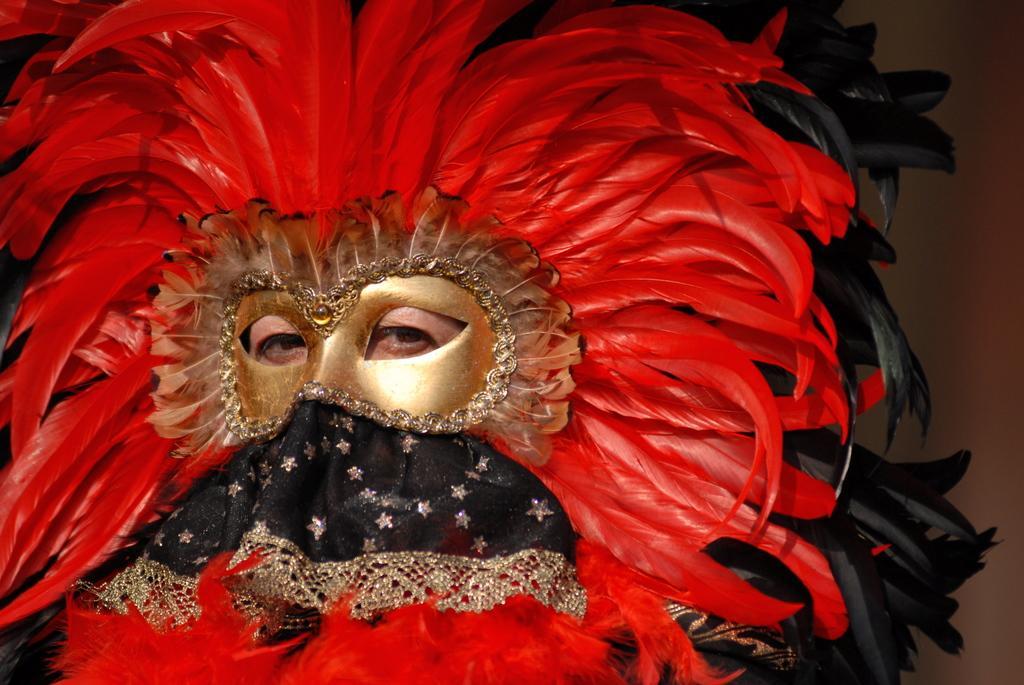How would you summarize this image in a sentence or two? There is a person, hiding the face with a mask. The mask is made up of red and black feathers. 